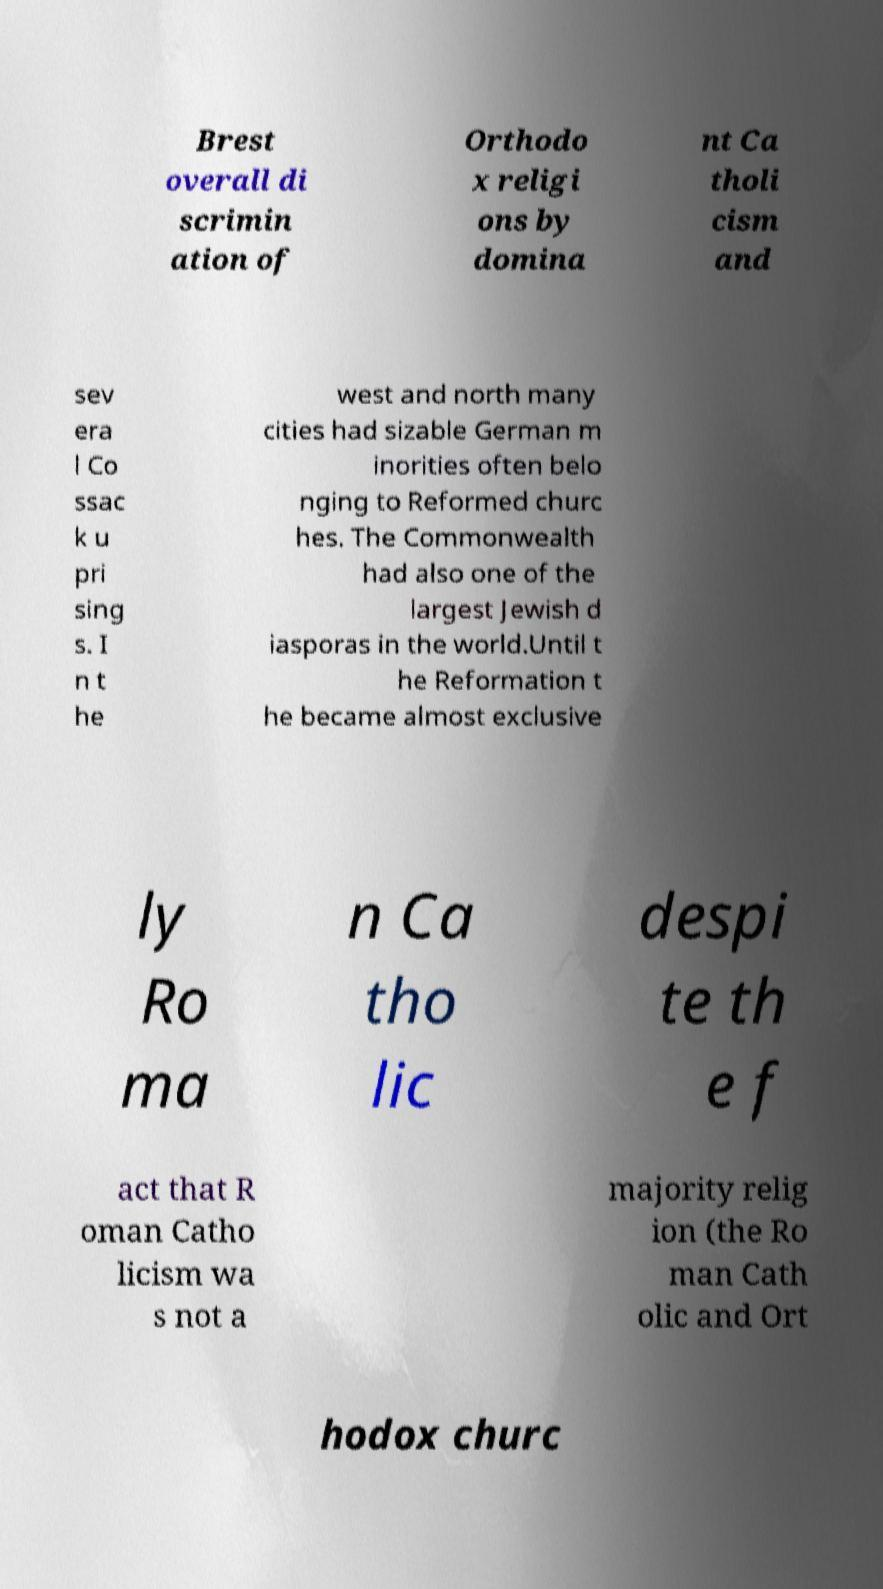For documentation purposes, I need the text within this image transcribed. Could you provide that? Brest overall di scrimin ation of Orthodo x religi ons by domina nt Ca tholi cism and sev era l Co ssac k u pri sing s. I n t he west and north many cities had sizable German m inorities often belo nging to Reformed churc hes. The Commonwealth had also one of the largest Jewish d iasporas in the world.Until t he Reformation t he became almost exclusive ly Ro ma n Ca tho lic despi te th e f act that R oman Catho licism wa s not a majority relig ion (the Ro man Cath olic and Ort hodox churc 